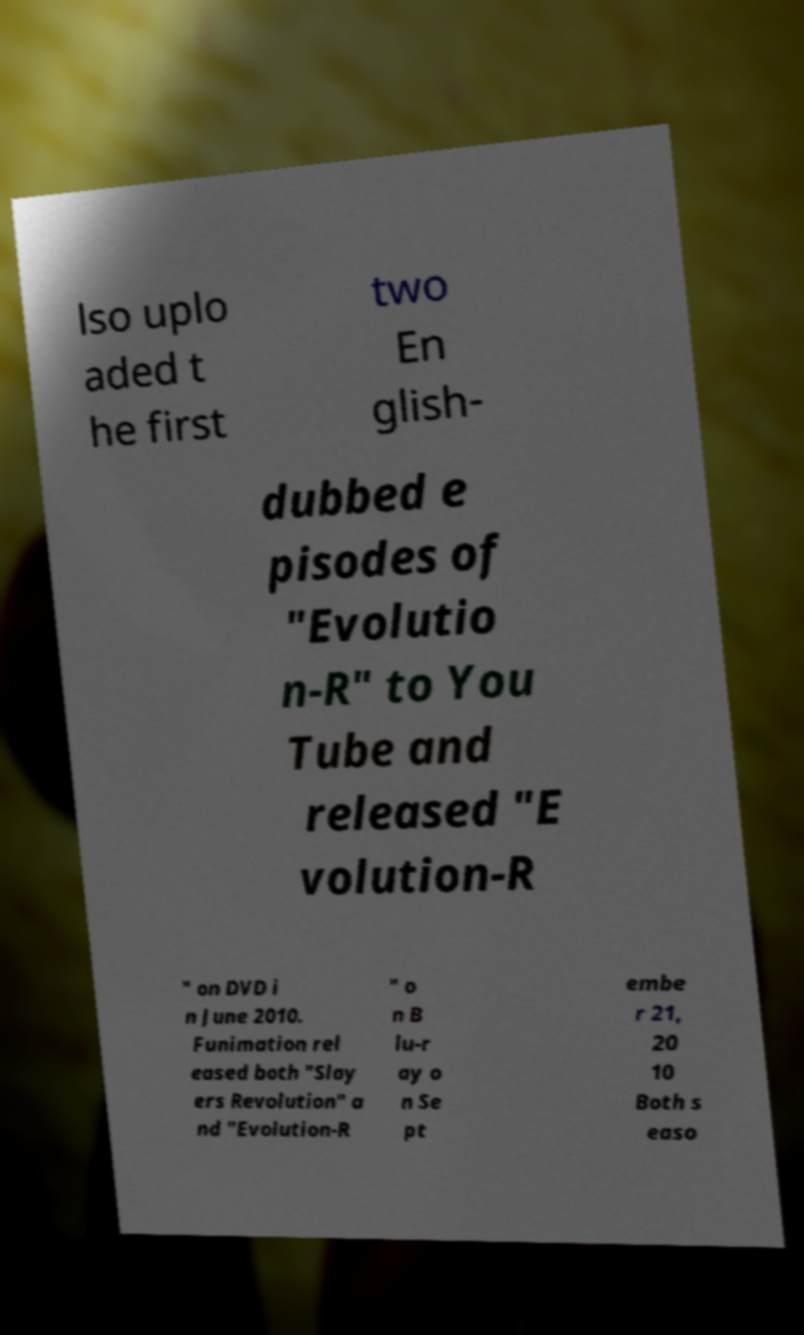Please identify and transcribe the text found in this image. lso uplo aded t he first two En glish- dubbed e pisodes of "Evolutio n-R" to You Tube and released "E volution-R " on DVD i n June 2010. Funimation rel eased both "Slay ers Revolution" a nd "Evolution-R " o n B lu-r ay o n Se pt embe r 21, 20 10 Both s easo 